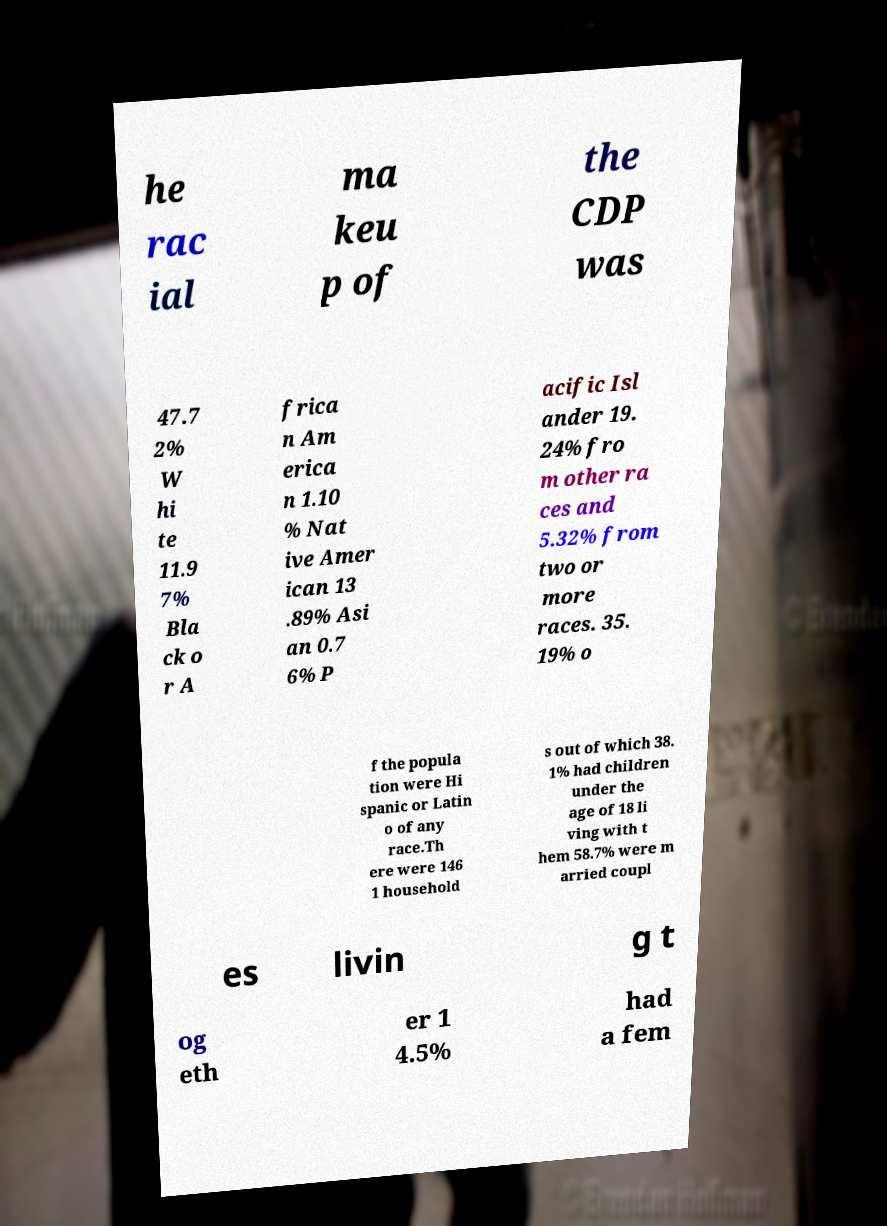Can you read and provide the text displayed in the image?This photo seems to have some interesting text. Can you extract and type it out for me? he rac ial ma keu p of the CDP was 47.7 2% W hi te 11.9 7% Bla ck o r A frica n Am erica n 1.10 % Nat ive Amer ican 13 .89% Asi an 0.7 6% P acific Isl ander 19. 24% fro m other ra ces and 5.32% from two or more races. 35. 19% o f the popula tion were Hi spanic or Latin o of any race.Th ere were 146 1 household s out of which 38. 1% had children under the age of 18 li ving with t hem 58.7% were m arried coupl es livin g t og eth er 1 4.5% had a fem 